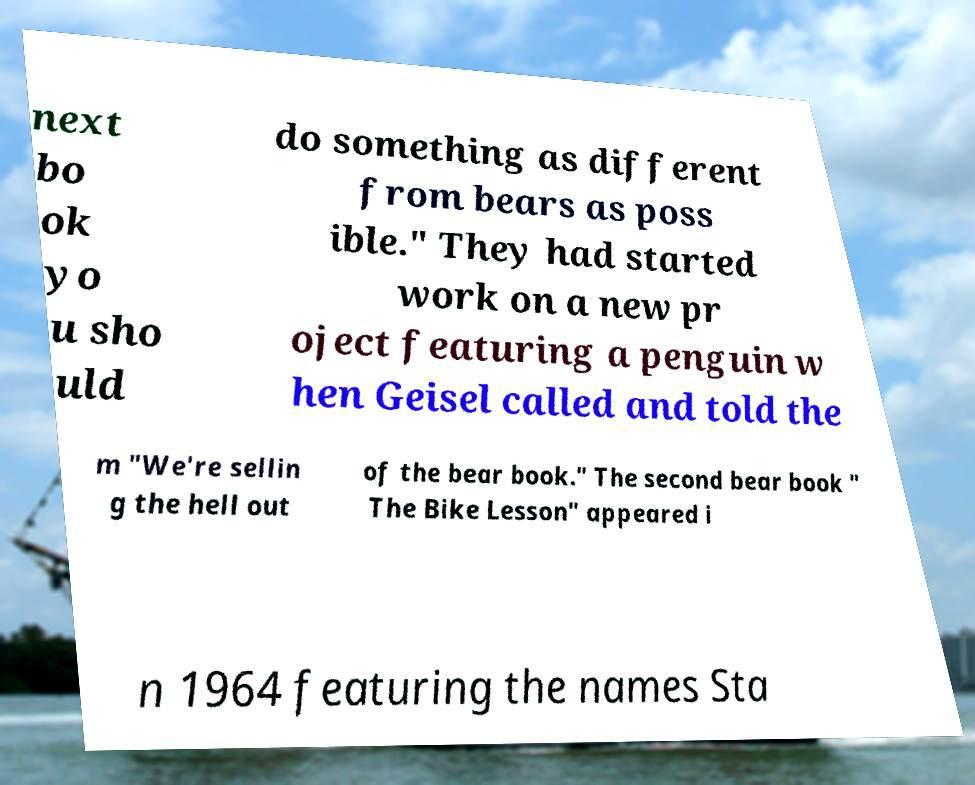Could you extract and type out the text from this image? next bo ok yo u sho uld do something as different from bears as poss ible." They had started work on a new pr oject featuring a penguin w hen Geisel called and told the m "We're sellin g the hell out of the bear book." The second bear book " The Bike Lesson" appeared i n 1964 featuring the names Sta 